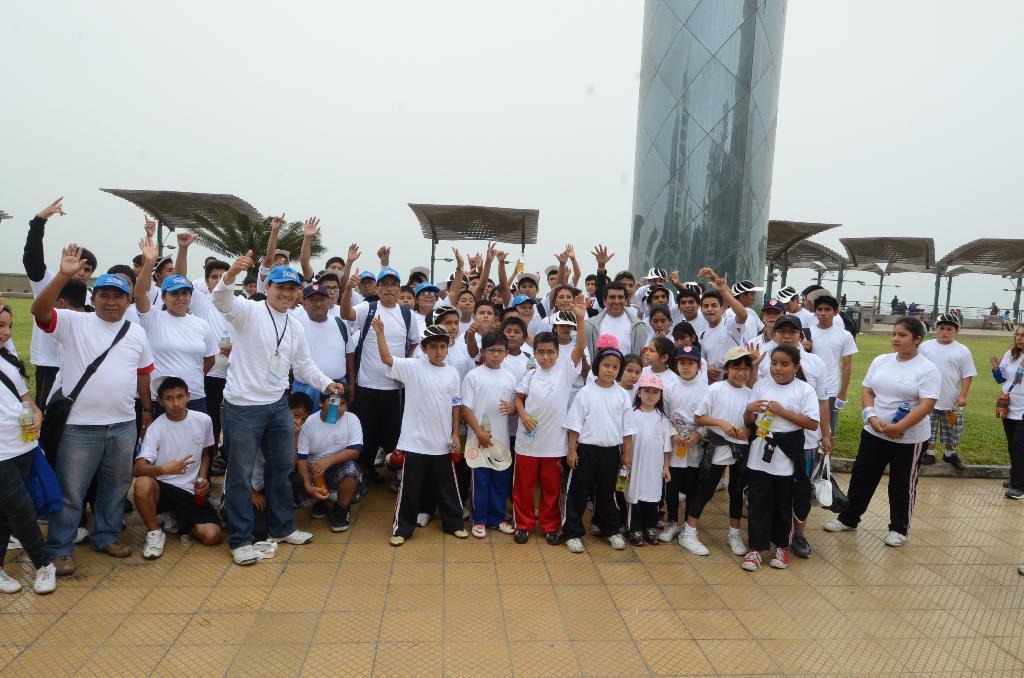Describe this image in one or two sentences. In this picture there are group of people standing and there are three people on knees. At the back there are sheds and there is a tower and there are trees. At the top there is sky. At the bottom there is a pavement and there is grass. On the right side of the image there are group of people under the shed. 